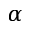Convert formula to latex. <formula><loc_0><loc_0><loc_500><loc_500>\alpha</formula> 